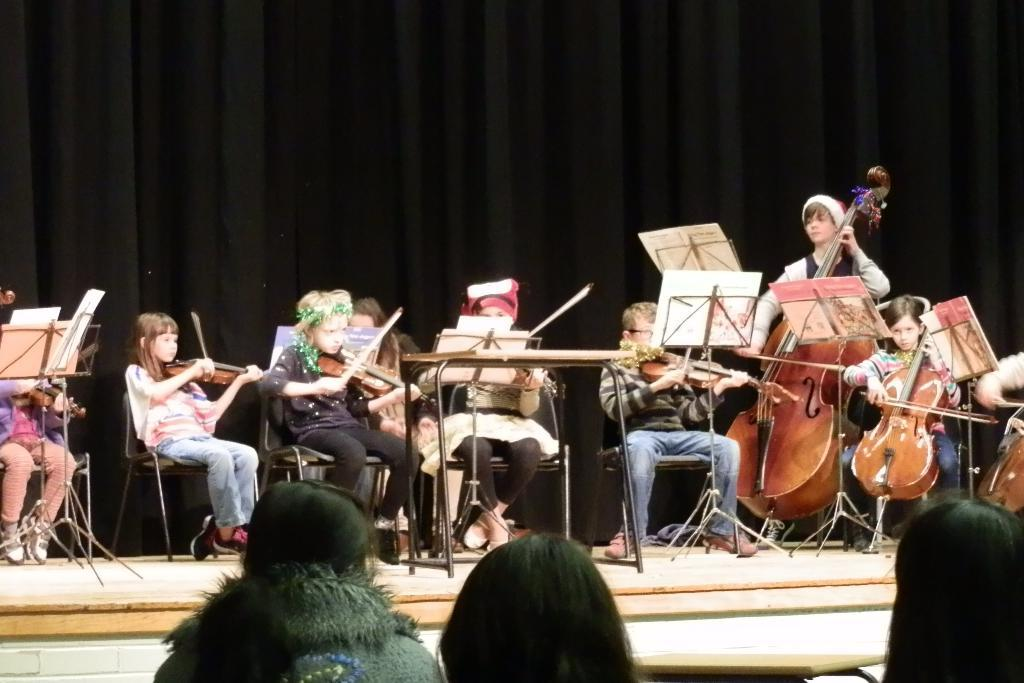What is happening in the image? There is a group of people in the image, and they are on chairs on a stage. What are the people doing on the stage? The people are holding musical instruments and playing them. What can be seen in the background of the image? The background of the image is black in color. How many roses are on the stage in the image? There are no roses present in the image; it features a group of people playing musical instruments on a stage with a black background. What type of chess pieces can be seen on the stage in the image? There are no chess pieces visible in the image; it features a group of people playing musical instruments on a stage with a black background. 